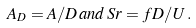<formula> <loc_0><loc_0><loc_500><loc_500>A _ { D } = A / D \, a n d \, S r = f D / U \, .</formula> 